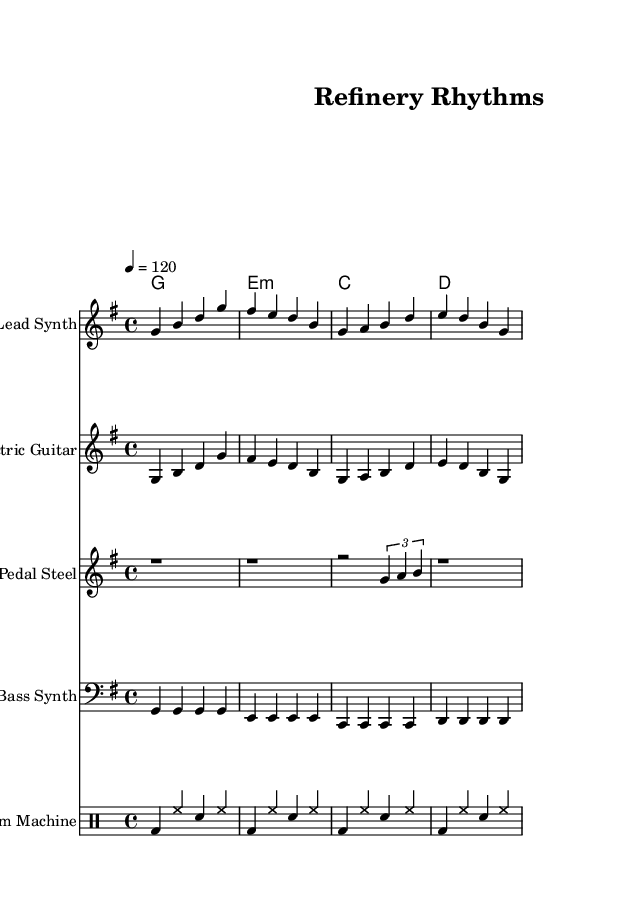What is the key signature of this music? The key signature indicated at the beginning of the score shows one sharp, which is consistent with G major. Therefore, the key signature is G major.
Answer: G major What is the time signature of the piece? The time signature is located next to the key signature at the beginning of the score. It is written as 4/4, indicating four beats per measure, with a quarter note receiving one beat.
Answer: 4/4 What is the tempo marking of this piece? The tempo marking can be found above the staff in the score, where it reads "4 = 120." This means the piece should be played at a speed of 120 beats per minute.
Answer: 120 How many instruments are featured in this score? By counting the different staffs in the score, we see that there are five distinct instrument parts (Lead Synth, Electric Guitar, Pedal Steel, Bass Synth, Drum Machine).
Answer: Five Which chord is used in the first measure? Looking at the chord section at the beginning of the score, the first chord written is G, which is also written as G major.
Answer: G What type of synthesizer is utilized for the bass part? The score identifies the instrument for the bass part as "Bass Synth," indicating that a synthesizer is being used specifically for the bass line.
Answer: Bass Synth How is the rhythm pattern characterized in the drum part? The drum part shows a consistent pattern of bass drum (bd) and hi-hat (hh) notes alternating with snare drum (sn) hits throughout the four measures, which creates a steady and driving rhythm typical in electronic music.
Answer: Steady rhythm 